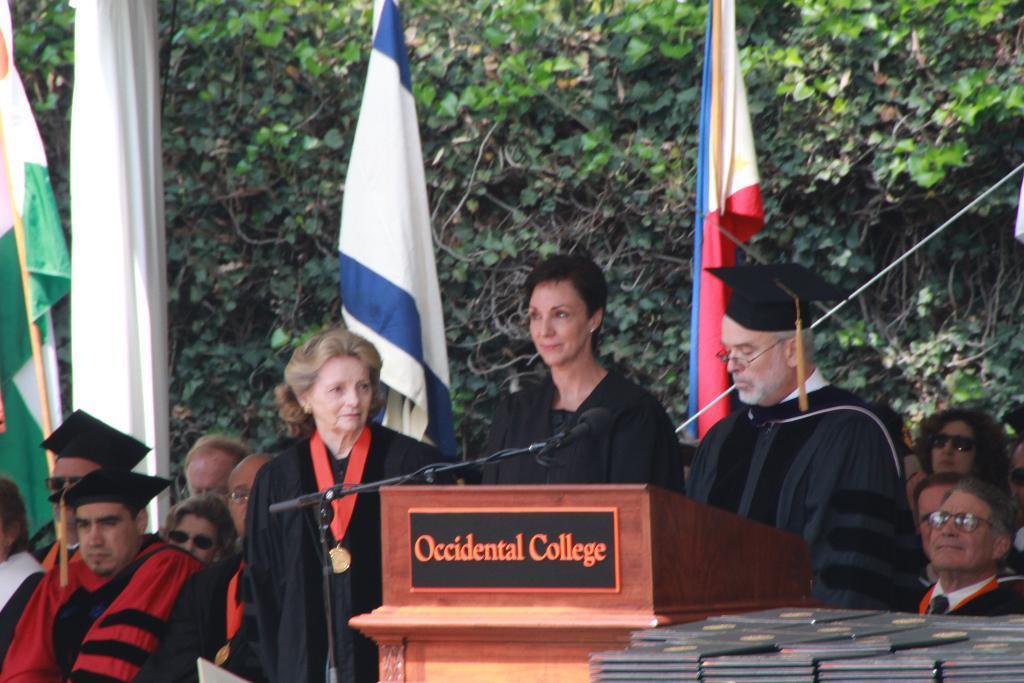In one or two sentences, can you explain what this image depicts? In this picture we can see some people standing here, two men on the left side wore hats, there is a speech desk here, we can see a microphone, in the background there are some flags and a cloth, we can see trees here, at the right bottom there are some files. 